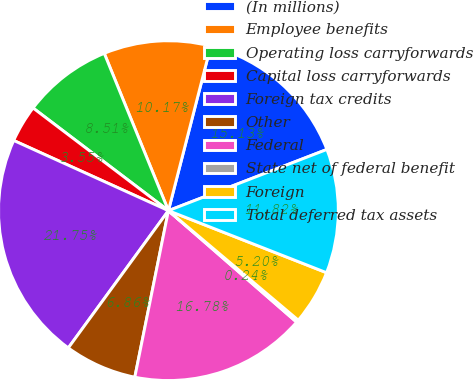Convert chart. <chart><loc_0><loc_0><loc_500><loc_500><pie_chart><fcel>(In millions)<fcel>Employee benefits<fcel>Operating loss carryforwards<fcel>Capital loss carryforwards<fcel>Foreign tax credits<fcel>Other<fcel>Federal<fcel>State net of federal benefit<fcel>Foreign<fcel>Total deferred tax assets<nl><fcel>15.13%<fcel>10.17%<fcel>8.51%<fcel>3.55%<fcel>21.75%<fcel>6.86%<fcel>16.78%<fcel>0.24%<fcel>5.2%<fcel>11.82%<nl></chart> 